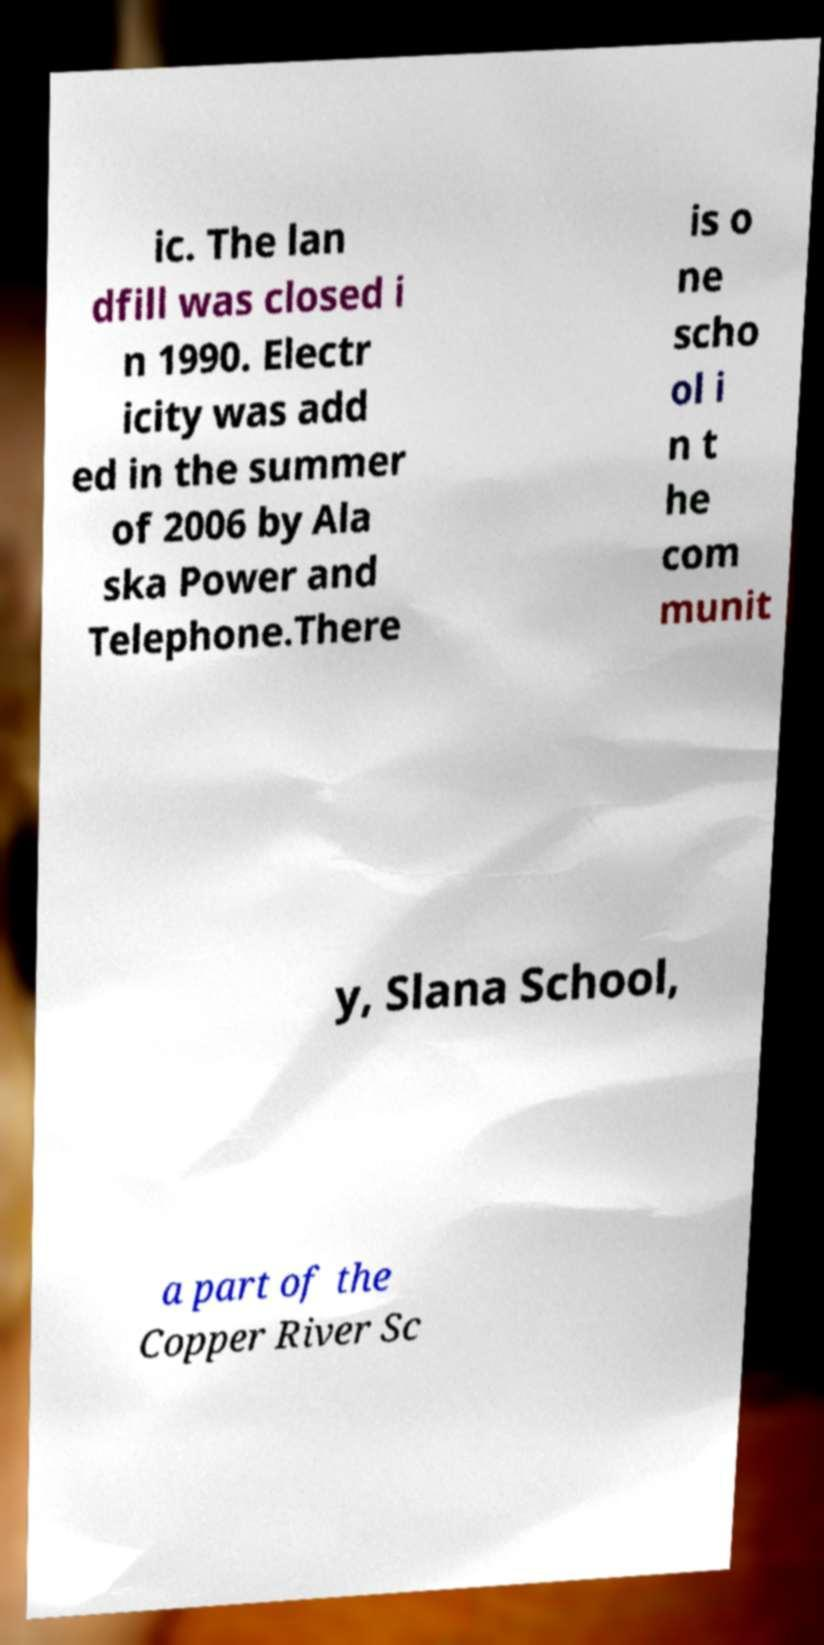Can you read and provide the text displayed in the image?This photo seems to have some interesting text. Can you extract and type it out for me? ic. The lan dfill was closed i n 1990. Electr icity was add ed in the summer of 2006 by Ala ska Power and Telephone.There is o ne scho ol i n t he com munit y, Slana School, a part of the Copper River Sc 